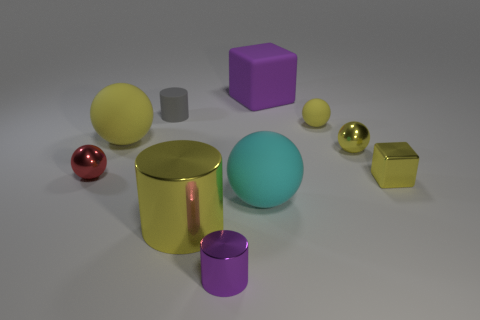There is a big metallic object that is the same color as the tiny rubber ball; what shape is it?
Offer a terse response. Cylinder. There is a yellow thing that is both in front of the red shiny sphere and on the right side of the large matte cube; what material is it?
Your response must be concise. Metal. What number of cylinders are small brown objects or tiny gray matte objects?
Your answer should be compact. 1. There is a big yellow thing that is the same shape as the small purple metal thing; what is it made of?
Give a very brief answer. Metal. There is a red sphere that is made of the same material as the small block; what size is it?
Offer a terse response. Small. Does the purple object that is behind the big yellow matte object have the same shape as the purple object that is in front of the red sphere?
Provide a short and direct response. No. What is the color of the big cylinder that is made of the same material as the red sphere?
Your answer should be very brief. Yellow. Is the size of the rubber sphere in front of the red metal thing the same as the yellow object that is in front of the cyan object?
Give a very brief answer. Yes. The object that is both behind the red metal object and left of the gray matte thing has what shape?
Ensure brevity in your answer.  Sphere. Is there a tiny yellow sphere that has the same material as the tiny yellow cube?
Make the answer very short. Yes. 